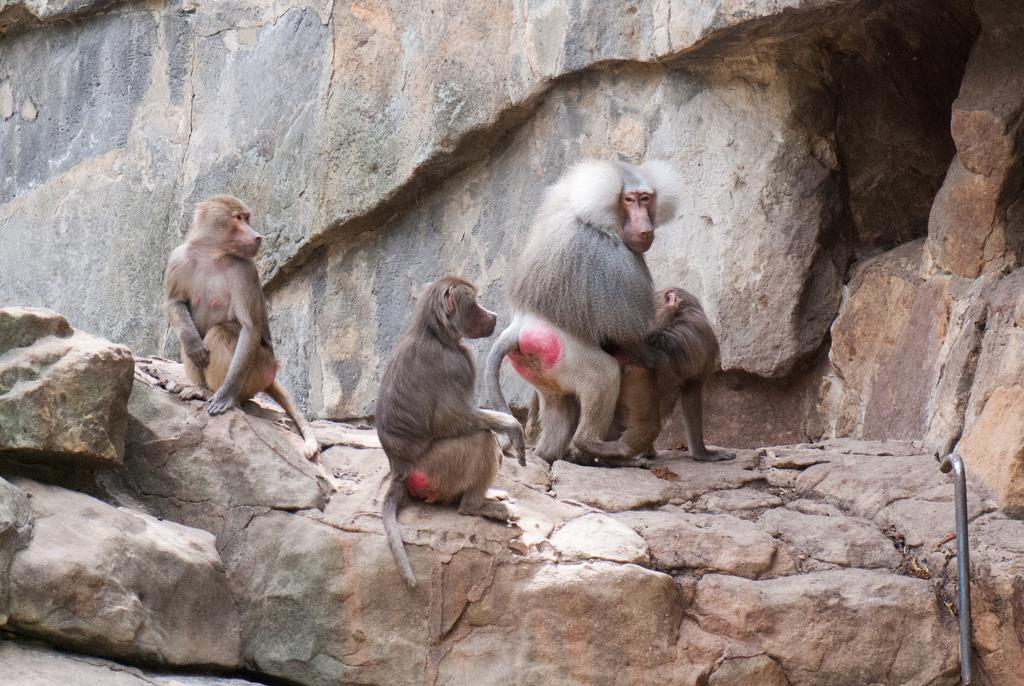What animals are present in the image? There is a group of monkeys on the rocks in the image. What object can be seen on the right side of the image? There is a rod on the right side of the image. What type of natural feature is visible in the background of the image? There is a rock wall in the background of the image. How many lizards are sitting on the elbow of the monkey in the image? There are no lizards or elbows visible in the image; it features a group of monkeys on rocks with a rod on the right side and a rock wall in the background. 